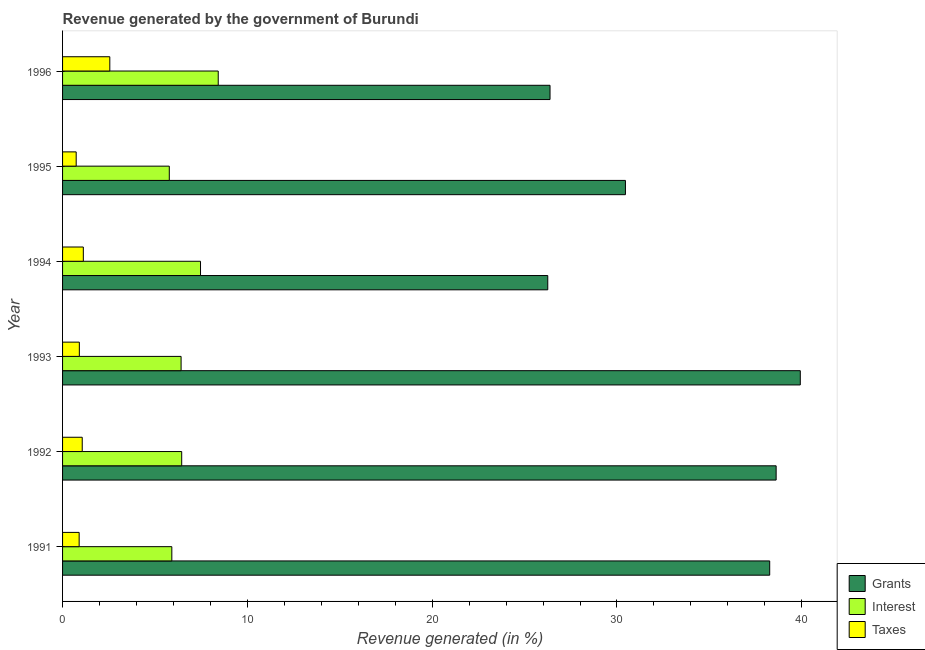How many groups of bars are there?
Give a very brief answer. 6. Are the number of bars on each tick of the Y-axis equal?
Provide a succinct answer. Yes. How many bars are there on the 6th tick from the top?
Provide a short and direct response. 3. How many bars are there on the 3rd tick from the bottom?
Offer a terse response. 3. What is the label of the 3rd group of bars from the top?
Your response must be concise. 1994. What is the percentage of revenue generated by taxes in 1992?
Provide a short and direct response. 1.06. Across all years, what is the maximum percentage of revenue generated by interest?
Provide a succinct answer. 8.42. Across all years, what is the minimum percentage of revenue generated by grants?
Provide a short and direct response. 26.26. What is the total percentage of revenue generated by taxes in the graph?
Make the answer very short. 7.29. What is the difference between the percentage of revenue generated by interest in 1994 and that in 1995?
Give a very brief answer. 1.69. What is the difference between the percentage of revenue generated by taxes in 1992 and the percentage of revenue generated by interest in 1994?
Make the answer very short. -6.4. What is the average percentage of revenue generated by grants per year?
Offer a terse response. 33.32. In the year 1994, what is the difference between the percentage of revenue generated by taxes and percentage of revenue generated by interest?
Give a very brief answer. -6.34. What is the ratio of the percentage of revenue generated by taxes in 1994 to that in 1995?
Give a very brief answer. 1.52. What is the difference between the highest and the second highest percentage of revenue generated by grants?
Your answer should be very brief. 1.31. What is the difference between the highest and the lowest percentage of revenue generated by interest?
Provide a succinct answer. 2.65. What does the 1st bar from the top in 1991 represents?
Offer a terse response. Taxes. What does the 1st bar from the bottom in 1996 represents?
Your answer should be very brief. Grants. Is it the case that in every year, the sum of the percentage of revenue generated by grants and percentage of revenue generated by interest is greater than the percentage of revenue generated by taxes?
Provide a succinct answer. Yes. Are all the bars in the graph horizontal?
Offer a very short reply. Yes. How many years are there in the graph?
Offer a terse response. 6. What is the difference between two consecutive major ticks on the X-axis?
Give a very brief answer. 10. Does the graph contain any zero values?
Your answer should be very brief. No. How many legend labels are there?
Your response must be concise. 3. What is the title of the graph?
Ensure brevity in your answer.  Revenue generated by the government of Burundi. What is the label or title of the X-axis?
Give a very brief answer. Revenue generated (in %). What is the Revenue generated (in %) of Grants in 1991?
Your response must be concise. 38.27. What is the Revenue generated (in %) of Interest in 1991?
Your answer should be very brief. 5.91. What is the Revenue generated (in %) of Taxes in 1991?
Your answer should be compact. 0.9. What is the Revenue generated (in %) in Grants in 1992?
Keep it short and to the point. 38.61. What is the Revenue generated (in %) in Interest in 1992?
Make the answer very short. 6.45. What is the Revenue generated (in %) in Taxes in 1992?
Offer a terse response. 1.06. What is the Revenue generated (in %) of Grants in 1993?
Offer a very short reply. 39.92. What is the Revenue generated (in %) in Interest in 1993?
Provide a short and direct response. 6.41. What is the Revenue generated (in %) in Taxes in 1993?
Offer a very short reply. 0.91. What is the Revenue generated (in %) in Grants in 1994?
Make the answer very short. 26.26. What is the Revenue generated (in %) of Interest in 1994?
Give a very brief answer. 7.47. What is the Revenue generated (in %) of Taxes in 1994?
Provide a succinct answer. 1.12. What is the Revenue generated (in %) in Grants in 1995?
Make the answer very short. 30.46. What is the Revenue generated (in %) in Interest in 1995?
Provide a succinct answer. 5.78. What is the Revenue generated (in %) of Taxes in 1995?
Your answer should be compact. 0.74. What is the Revenue generated (in %) of Grants in 1996?
Offer a very short reply. 26.38. What is the Revenue generated (in %) in Interest in 1996?
Offer a terse response. 8.42. What is the Revenue generated (in %) of Taxes in 1996?
Provide a succinct answer. 2.56. Across all years, what is the maximum Revenue generated (in %) in Grants?
Make the answer very short. 39.92. Across all years, what is the maximum Revenue generated (in %) of Interest?
Make the answer very short. 8.42. Across all years, what is the maximum Revenue generated (in %) of Taxes?
Offer a very short reply. 2.56. Across all years, what is the minimum Revenue generated (in %) of Grants?
Your answer should be compact. 26.26. Across all years, what is the minimum Revenue generated (in %) of Interest?
Make the answer very short. 5.78. Across all years, what is the minimum Revenue generated (in %) of Taxes?
Keep it short and to the point. 0.74. What is the total Revenue generated (in %) in Grants in the graph?
Make the answer very short. 199.89. What is the total Revenue generated (in %) in Interest in the graph?
Provide a short and direct response. 40.44. What is the total Revenue generated (in %) of Taxes in the graph?
Make the answer very short. 7.29. What is the difference between the Revenue generated (in %) in Grants in 1991 and that in 1992?
Keep it short and to the point. -0.35. What is the difference between the Revenue generated (in %) of Interest in 1991 and that in 1992?
Provide a short and direct response. -0.53. What is the difference between the Revenue generated (in %) of Taxes in 1991 and that in 1992?
Provide a short and direct response. -0.17. What is the difference between the Revenue generated (in %) in Grants in 1991 and that in 1993?
Your response must be concise. -1.66. What is the difference between the Revenue generated (in %) of Interest in 1991 and that in 1993?
Ensure brevity in your answer.  -0.5. What is the difference between the Revenue generated (in %) of Taxes in 1991 and that in 1993?
Offer a very short reply. -0.01. What is the difference between the Revenue generated (in %) in Grants in 1991 and that in 1994?
Offer a terse response. 12.01. What is the difference between the Revenue generated (in %) in Interest in 1991 and that in 1994?
Keep it short and to the point. -1.55. What is the difference between the Revenue generated (in %) of Taxes in 1991 and that in 1994?
Provide a short and direct response. -0.23. What is the difference between the Revenue generated (in %) of Grants in 1991 and that in 1995?
Provide a succinct answer. 7.81. What is the difference between the Revenue generated (in %) of Interest in 1991 and that in 1995?
Give a very brief answer. 0.14. What is the difference between the Revenue generated (in %) of Taxes in 1991 and that in 1995?
Give a very brief answer. 0.16. What is the difference between the Revenue generated (in %) of Grants in 1991 and that in 1996?
Offer a very short reply. 11.89. What is the difference between the Revenue generated (in %) of Interest in 1991 and that in 1996?
Your answer should be compact. -2.51. What is the difference between the Revenue generated (in %) in Taxes in 1991 and that in 1996?
Ensure brevity in your answer.  -1.66. What is the difference between the Revenue generated (in %) in Grants in 1992 and that in 1993?
Ensure brevity in your answer.  -1.31. What is the difference between the Revenue generated (in %) in Interest in 1992 and that in 1993?
Give a very brief answer. 0.03. What is the difference between the Revenue generated (in %) of Taxes in 1992 and that in 1993?
Ensure brevity in your answer.  0.16. What is the difference between the Revenue generated (in %) of Grants in 1992 and that in 1994?
Your response must be concise. 12.36. What is the difference between the Revenue generated (in %) of Interest in 1992 and that in 1994?
Make the answer very short. -1.02. What is the difference between the Revenue generated (in %) in Taxes in 1992 and that in 1994?
Your answer should be very brief. -0.06. What is the difference between the Revenue generated (in %) of Grants in 1992 and that in 1995?
Ensure brevity in your answer.  8.16. What is the difference between the Revenue generated (in %) of Interest in 1992 and that in 1995?
Make the answer very short. 0.67. What is the difference between the Revenue generated (in %) in Taxes in 1992 and that in 1995?
Ensure brevity in your answer.  0.33. What is the difference between the Revenue generated (in %) in Grants in 1992 and that in 1996?
Provide a short and direct response. 12.24. What is the difference between the Revenue generated (in %) of Interest in 1992 and that in 1996?
Keep it short and to the point. -1.98. What is the difference between the Revenue generated (in %) in Taxes in 1992 and that in 1996?
Provide a short and direct response. -1.49. What is the difference between the Revenue generated (in %) in Grants in 1993 and that in 1994?
Offer a terse response. 13.67. What is the difference between the Revenue generated (in %) of Interest in 1993 and that in 1994?
Offer a terse response. -1.05. What is the difference between the Revenue generated (in %) in Taxes in 1993 and that in 1994?
Offer a terse response. -0.22. What is the difference between the Revenue generated (in %) in Grants in 1993 and that in 1995?
Make the answer very short. 9.46. What is the difference between the Revenue generated (in %) of Interest in 1993 and that in 1995?
Your response must be concise. 0.64. What is the difference between the Revenue generated (in %) of Taxes in 1993 and that in 1995?
Your answer should be compact. 0.17. What is the difference between the Revenue generated (in %) of Grants in 1993 and that in 1996?
Keep it short and to the point. 13.54. What is the difference between the Revenue generated (in %) in Interest in 1993 and that in 1996?
Keep it short and to the point. -2.01. What is the difference between the Revenue generated (in %) in Taxes in 1993 and that in 1996?
Offer a terse response. -1.65. What is the difference between the Revenue generated (in %) of Grants in 1994 and that in 1995?
Your answer should be very brief. -4.2. What is the difference between the Revenue generated (in %) in Interest in 1994 and that in 1995?
Give a very brief answer. 1.69. What is the difference between the Revenue generated (in %) in Taxes in 1994 and that in 1995?
Keep it short and to the point. 0.39. What is the difference between the Revenue generated (in %) in Grants in 1994 and that in 1996?
Make the answer very short. -0.12. What is the difference between the Revenue generated (in %) of Interest in 1994 and that in 1996?
Your answer should be very brief. -0.96. What is the difference between the Revenue generated (in %) of Taxes in 1994 and that in 1996?
Provide a short and direct response. -1.43. What is the difference between the Revenue generated (in %) in Grants in 1995 and that in 1996?
Ensure brevity in your answer.  4.08. What is the difference between the Revenue generated (in %) of Interest in 1995 and that in 1996?
Your response must be concise. -2.65. What is the difference between the Revenue generated (in %) of Taxes in 1995 and that in 1996?
Make the answer very short. -1.82. What is the difference between the Revenue generated (in %) of Grants in 1991 and the Revenue generated (in %) of Interest in 1992?
Provide a succinct answer. 31.82. What is the difference between the Revenue generated (in %) of Grants in 1991 and the Revenue generated (in %) of Taxes in 1992?
Ensure brevity in your answer.  37.2. What is the difference between the Revenue generated (in %) in Interest in 1991 and the Revenue generated (in %) in Taxes in 1992?
Your response must be concise. 4.85. What is the difference between the Revenue generated (in %) in Grants in 1991 and the Revenue generated (in %) in Interest in 1993?
Provide a short and direct response. 31.85. What is the difference between the Revenue generated (in %) in Grants in 1991 and the Revenue generated (in %) in Taxes in 1993?
Make the answer very short. 37.36. What is the difference between the Revenue generated (in %) of Interest in 1991 and the Revenue generated (in %) of Taxes in 1993?
Ensure brevity in your answer.  5. What is the difference between the Revenue generated (in %) in Grants in 1991 and the Revenue generated (in %) in Interest in 1994?
Your answer should be compact. 30.8. What is the difference between the Revenue generated (in %) in Grants in 1991 and the Revenue generated (in %) in Taxes in 1994?
Offer a very short reply. 37.14. What is the difference between the Revenue generated (in %) of Interest in 1991 and the Revenue generated (in %) of Taxes in 1994?
Make the answer very short. 4.79. What is the difference between the Revenue generated (in %) in Grants in 1991 and the Revenue generated (in %) in Interest in 1995?
Offer a very short reply. 32.49. What is the difference between the Revenue generated (in %) of Grants in 1991 and the Revenue generated (in %) of Taxes in 1995?
Provide a succinct answer. 37.53. What is the difference between the Revenue generated (in %) in Interest in 1991 and the Revenue generated (in %) in Taxes in 1995?
Give a very brief answer. 5.18. What is the difference between the Revenue generated (in %) in Grants in 1991 and the Revenue generated (in %) in Interest in 1996?
Provide a succinct answer. 29.84. What is the difference between the Revenue generated (in %) in Grants in 1991 and the Revenue generated (in %) in Taxes in 1996?
Offer a terse response. 35.71. What is the difference between the Revenue generated (in %) in Interest in 1991 and the Revenue generated (in %) in Taxes in 1996?
Make the answer very short. 3.36. What is the difference between the Revenue generated (in %) of Grants in 1992 and the Revenue generated (in %) of Interest in 1993?
Provide a short and direct response. 32.2. What is the difference between the Revenue generated (in %) in Grants in 1992 and the Revenue generated (in %) in Taxes in 1993?
Give a very brief answer. 37.71. What is the difference between the Revenue generated (in %) in Interest in 1992 and the Revenue generated (in %) in Taxes in 1993?
Keep it short and to the point. 5.54. What is the difference between the Revenue generated (in %) of Grants in 1992 and the Revenue generated (in %) of Interest in 1994?
Give a very brief answer. 31.15. What is the difference between the Revenue generated (in %) of Grants in 1992 and the Revenue generated (in %) of Taxes in 1994?
Ensure brevity in your answer.  37.49. What is the difference between the Revenue generated (in %) of Interest in 1992 and the Revenue generated (in %) of Taxes in 1994?
Make the answer very short. 5.32. What is the difference between the Revenue generated (in %) in Grants in 1992 and the Revenue generated (in %) in Interest in 1995?
Offer a terse response. 32.84. What is the difference between the Revenue generated (in %) of Grants in 1992 and the Revenue generated (in %) of Taxes in 1995?
Your answer should be very brief. 37.88. What is the difference between the Revenue generated (in %) of Interest in 1992 and the Revenue generated (in %) of Taxes in 1995?
Keep it short and to the point. 5.71. What is the difference between the Revenue generated (in %) of Grants in 1992 and the Revenue generated (in %) of Interest in 1996?
Your answer should be compact. 30.19. What is the difference between the Revenue generated (in %) of Grants in 1992 and the Revenue generated (in %) of Taxes in 1996?
Give a very brief answer. 36.06. What is the difference between the Revenue generated (in %) of Interest in 1992 and the Revenue generated (in %) of Taxes in 1996?
Make the answer very short. 3.89. What is the difference between the Revenue generated (in %) in Grants in 1993 and the Revenue generated (in %) in Interest in 1994?
Provide a short and direct response. 32.46. What is the difference between the Revenue generated (in %) of Grants in 1993 and the Revenue generated (in %) of Taxes in 1994?
Provide a short and direct response. 38.8. What is the difference between the Revenue generated (in %) of Interest in 1993 and the Revenue generated (in %) of Taxes in 1994?
Your answer should be very brief. 5.29. What is the difference between the Revenue generated (in %) of Grants in 1993 and the Revenue generated (in %) of Interest in 1995?
Provide a short and direct response. 34.15. What is the difference between the Revenue generated (in %) of Grants in 1993 and the Revenue generated (in %) of Taxes in 1995?
Provide a succinct answer. 39.18. What is the difference between the Revenue generated (in %) in Interest in 1993 and the Revenue generated (in %) in Taxes in 1995?
Keep it short and to the point. 5.68. What is the difference between the Revenue generated (in %) in Grants in 1993 and the Revenue generated (in %) in Interest in 1996?
Give a very brief answer. 31.5. What is the difference between the Revenue generated (in %) in Grants in 1993 and the Revenue generated (in %) in Taxes in 1996?
Provide a succinct answer. 37.36. What is the difference between the Revenue generated (in %) in Interest in 1993 and the Revenue generated (in %) in Taxes in 1996?
Offer a very short reply. 3.86. What is the difference between the Revenue generated (in %) of Grants in 1994 and the Revenue generated (in %) of Interest in 1995?
Provide a succinct answer. 20.48. What is the difference between the Revenue generated (in %) in Grants in 1994 and the Revenue generated (in %) in Taxes in 1995?
Your answer should be very brief. 25.52. What is the difference between the Revenue generated (in %) in Interest in 1994 and the Revenue generated (in %) in Taxes in 1995?
Your answer should be very brief. 6.73. What is the difference between the Revenue generated (in %) in Grants in 1994 and the Revenue generated (in %) in Interest in 1996?
Give a very brief answer. 17.83. What is the difference between the Revenue generated (in %) of Grants in 1994 and the Revenue generated (in %) of Taxes in 1996?
Your answer should be very brief. 23.7. What is the difference between the Revenue generated (in %) of Interest in 1994 and the Revenue generated (in %) of Taxes in 1996?
Offer a terse response. 4.91. What is the difference between the Revenue generated (in %) of Grants in 1995 and the Revenue generated (in %) of Interest in 1996?
Give a very brief answer. 22.03. What is the difference between the Revenue generated (in %) of Grants in 1995 and the Revenue generated (in %) of Taxes in 1996?
Ensure brevity in your answer.  27.9. What is the difference between the Revenue generated (in %) in Interest in 1995 and the Revenue generated (in %) in Taxes in 1996?
Your response must be concise. 3.22. What is the average Revenue generated (in %) of Grants per year?
Your answer should be compact. 33.32. What is the average Revenue generated (in %) of Interest per year?
Provide a succinct answer. 6.74. What is the average Revenue generated (in %) of Taxes per year?
Offer a terse response. 1.21. In the year 1991, what is the difference between the Revenue generated (in %) in Grants and Revenue generated (in %) in Interest?
Keep it short and to the point. 32.35. In the year 1991, what is the difference between the Revenue generated (in %) of Grants and Revenue generated (in %) of Taxes?
Make the answer very short. 37.37. In the year 1991, what is the difference between the Revenue generated (in %) in Interest and Revenue generated (in %) in Taxes?
Your answer should be compact. 5.01. In the year 1992, what is the difference between the Revenue generated (in %) in Grants and Revenue generated (in %) in Interest?
Keep it short and to the point. 32.17. In the year 1992, what is the difference between the Revenue generated (in %) of Grants and Revenue generated (in %) of Taxes?
Offer a terse response. 37.55. In the year 1992, what is the difference between the Revenue generated (in %) of Interest and Revenue generated (in %) of Taxes?
Your answer should be very brief. 5.38. In the year 1993, what is the difference between the Revenue generated (in %) in Grants and Revenue generated (in %) in Interest?
Your answer should be compact. 33.51. In the year 1993, what is the difference between the Revenue generated (in %) of Grants and Revenue generated (in %) of Taxes?
Make the answer very short. 39.01. In the year 1993, what is the difference between the Revenue generated (in %) in Interest and Revenue generated (in %) in Taxes?
Ensure brevity in your answer.  5.51. In the year 1994, what is the difference between the Revenue generated (in %) in Grants and Revenue generated (in %) in Interest?
Offer a very short reply. 18.79. In the year 1994, what is the difference between the Revenue generated (in %) of Grants and Revenue generated (in %) of Taxes?
Make the answer very short. 25.13. In the year 1994, what is the difference between the Revenue generated (in %) of Interest and Revenue generated (in %) of Taxes?
Provide a succinct answer. 6.34. In the year 1995, what is the difference between the Revenue generated (in %) in Grants and Revenue generated (in %) in Interest?
Offer a terse response. 24.68. In the year 1995, what is the difference between the Revenue generated (in %) of Grants and Revenue generated (in %) of Taxes?
Your answer should be compact. 29.72. In the year 1995, what is the difference between the Revenue generated (in %) of Interest and Revenue generated (in %) of Taxes?
Make the answer very short. 5.04. In the year 1996, what is the difference between the Revenue generated (in %) of Grants and Revenue generated (in %) of Interest?
Offer a very short reply. 17.95. In the year 1996, what is the difference between the Revenue generated (in %) of Grants and Revenue generated (in %) of Taxes?
Keep it short and to the point. 23.82. In the year 1996, what is the difference between the Revenue generated (in %) in Interest and Revenue generated (in %) in Taxes?
Keep it short and to the point. 5.87. What is the ratio of the Revenue generated (in %) of Interest in 1991 to that in 1992?
Keep it short and to the point. 0.92. What is the ratio of the Revenue generated (in %) of Taxes in 1991 to that in 1992?
Provide a short and direct response. 0.84. What is the ratio of the Revenue generated (in %) in Grants in 1991 to that in 1993?
Your answer should be compact. 0.96. What is the ratio of the Revenue generated (in %) of Interest in 1991 to that in 1993?
Give a very brief answer. 0.92. What is the ratio of the Revenue generated (in %) in Taxes in 1991 to that in 1993?
Your answer should be compact. 0.99. What is the ratio of the Revenue generated (in %) of Grants in 1991 to that in 1994?
Ensure brevity in your answer.  1.46. What is the ratio of the Revenue generated (in %) in Interest in 1991 to that in 1994?
Make the answer very short. 0.79. What is the ratio of the Revenue generated (in %) in Taxes in 1991 to that in 1994?
Offer a terse response. 0.8. What is the ratio of the Revenue generated (in %) of Grants in 1991 to that in 1995?
Provide a short and direct response. 1.26. What is the ratio of the Revenue generated (in %) of Interest in 1991 to that in 1995?
Your answer should be compact. 1.02. What is the ratio of the Revenue generated (in %) in Taxes in 1991 to that in 1995?
Your answer should be very brief. 1.22. What is the ratio of the Revenue generated (in %) of Grants in 1991 to that in 1996?
Keep it short and to the point. 1.45. What is the ratio of the Revenue generated (in %) of Interest in 1991 to that in 1996?
Your answer should be very brief. 0.7. What is the ratio of the Revenue generated (in %) in Taxes in 1991 to that in 1996?
Provide a short and direct response. 0.35. What is the ratio of the Revenue generated (in %) of Grants in 1992 to that in 1993?
Your response must be concise. 0.97. What is the ratio of the Revenue generated (in %) in Interest in 1992 to that in 1993?
Provide a short and direct response. 1.01. What is the ratio of the Revenue generated (in %) of Taxes in 1992 to that in 1993?
Provide a short and direct response. 1.17. What is the ratio of the Revenue generated (in %) in Grants in 1992 to that in 1994?
Keep it short and to the point. 1.47. What is the ratio of the Revenue generated (in %) in Interest in 1992 to that in 1994?
Make the answer very short. 0.86. What is the ratio of the Revenue generated (in %) in Taxes in 1992 to that in 1994?
Provide a short and direct response. 0.95. What is the ratio of the Revenue generated (in %) in Grants in 1992 to that in 1995?
Keep it short and to the point. 1.27. What is the ratio of the Revenue generated (in %) of Interest in 1992 to that in 1995?
Offer a very short reply. 1.12. What is the ratio of the Revenue generated (in %) of Taxes in 1992 to that in 1995?
Offer a terse response. 1.44. What is the ratio of the Revenue generated (in %) of Grants in 1992 to that in 1996?
Make the answer very short. 1.46. What is the ratio of the Revenue generated (in %) in Interest in 1992 to that in 1996?
Make the answer very short. 0.77. What is the ratio of the Revenue generated (in %) of Taxes in 1992 to that in 1996?
Provide a succinct answer. 0.42. What is the ratio of the Revenue generated (in %) in Grants in 1993 to that in 1994?
Provide a short and direct response. 1.52. What is the ratio of the Revenue generated (in %) of Interest in 1993 to that in 1994?
Your response must be concise. 0.86. What is the ratio of the Revenue generated (in %) in Taxes in 1993 to that in 1994?
Make the answer very short. 0.81. What is the ratio of the Revenue generated (in %) of Grants in 1993 to that in 1995?
Provide a short and direct response. 1.31. What is the ratio of the Revenue generated (in %) in Interest in 1993 to that in 1995?
Make the answer very short. 1.11. What is the ratio of the Revenue generated (in %) in Taxes in 1993 to that in 1995?
Provide a succinct answer. 1.23. What is the ratio of the Revenue generated (in %) in Grants in 1993 to that in 1996?
Offer a terse response. 1.51. What is the ratio of the Revenue generated (in %) in Interest in 1993 to that in 1996?
Provide a succinct answer. 0.76. What is the ratio of the Revenue generated (in %) in Taxes in 1993 to that in 1996?
Provide a short and direct response. 0.36. What is the ratio of the Revenue generated (in %) of Grants in 1994 to that in 1995?
Your answer should be very brief. 0.86. What is the ratio of the Revenue generated (in %) in Interest in 1994 to that in 1995?
Your response must be concise. 1.29. What is the ratio of the Revenue generated (in %) of Taxes in 1994 to that in 1995?
Offer a very short reply. 1.52. What is the ratio of the Revenue generated (in %) in Interest in 1994 to that in 1996?
Your answer should be very brief. 0.89. What is the ratio of the Revenue generated (in %) of Taxes in 1994 to that in 1996?
Keep it short and to the point. 0.44. What is the ratio of the Revenue generated (in %) of Grants in 1995 to that in 1996?
Make the answer very short. 1.15. What is the ratio of the Revenue generated (in %) of Interest in 1995 to that in 1996?
Keep it short and to the point. 0.69. What is the ratio of the Revenue generated (in %) of Taxes in 1995 to that in 1996?
Make the answer very short. 0.29. What is the difference between the highest and the second highest Revenue generated (in %) of Grants?
Offer a terse response. 1.31. What is the difference between the highest and the second highest Revenue generated (in %) in Interest?
Keep it short and to the point. 0.96. What is the difference between the highest and the second highest Revenue generated (in %) in Taxes?
Keep it short and to the point. 1.43. What is the difference between the highest and the lowest Revenue generated (in %) of Grants?
Offer a very short reply. 13.67. What is the difference between the highest and the lowest Revenue generated (in %) of Interest?
Offer a terse response. 2.65. What is the difference between the highest and the lowest Revenue generated (in %) of Taxes?
Your answer should be very brief. 1.82. 